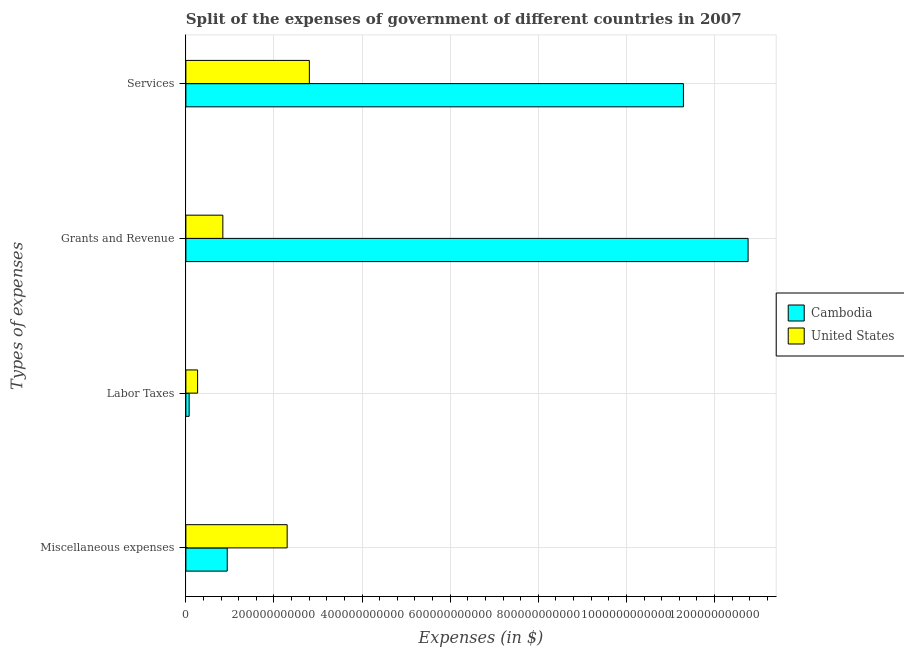How many different coloured bars are there?
Ensure brevity in your answer.  2. Are the number of bars per tick equal to the number of legend labels?
Your answer should be compact. Yes. How many bars are there on the 3rd tick from the top?
Keep it short and to the point. 2. How many bars are there on the 3rd tick from the bottom?
Offer a very short reply. 2. What is the label of the 3rd group of bars from the top?
Your answer should be very brief. Labor Taxes. What is the amount spent on services in Cambodia?
Offer a very short reply. 1.13e+12. Across all countries, what is the maximum amount spent on miscellaneous expenses?
Offer a very short reply. 2.30e+11. Across all countries, what is the minimum amount spent on grants and revenue?
Provide a short and direct response. 8.39e+1. In which country was the amount spent on miscellaneous expenses minimum?
Your answer should be compact. Cambodia. What is the total amount spent on labor taxes in the graph?
Offer a very short reply. 3.40e+1. What is the difference between the amount spent on services in United States and that in Cambodia?
Make the answer very short. -8.49e+11. What is the difference between the amount spent on miscellaneous expenses in Cambodia and the amount spent on services in United States?
Ensure brevity in your answer.  -1.86e+11. What is the average amount spent on services per country?
Provide a succinct answer. 7.05e+11. What is the difference between the amount spent on labor taxes and amount spent on grants and revenue in United States?
Provide a succinct answer. -5.73e+1. In how many countries, is the amount spent on grants and revenue greater than 1200000000000 $?
Your answer should be very brief. 1. What is the ratio of the amount spent on services in Cambodia to that in United States?
Provide a short and direct response. 4.03. Is the difference between the amount spent on miscellaneous expenses in Cambodia and United States greater than the difference between the amount spent on labor taxes in Cambodia and United States?
Offer a terse response. No. What is the difference between the highest and the second highest amount spent on miscellaneous expenses?
Your response must be concise. 1.36e+11. What is the difference between the highest and the lowest amount spent on grants and revenue?
Keep it short and to the point. 1.19e+12. In how many countries, is the amount spent on miscellaneous expenses greater than the average amount spent on miscellaneous expenses taken over all countries?
Keep it short and to the point. 1. Is the sum of the amount spent on grants and revenue in Cambodia and United States greater than the maximum amount spent on services across all countries?
Your response must be concise. Yes. What does the 2nd bar from the top in Services represents?
Ensure brevity in your answer.  Cambodia. What does the 1st bar from the bottom in Miscellaneous expenses represents?
Your answer should be very brief. Cambodia. How many bars are there?
Your answer should be very brief. 8. Are all the bars in the graph horizontal?
Give a very brief answer. Yes. What is the difference between two consecutive major ticks on the X-axis?
Make the answer very short. 2.00e+11. Does the graph contain any zero values?
Offer a terse response. No. Does the graph contain grids?
Offer a terse response. Yes. How many legend labels are there?
Provide a succinct answer. 2. How are the legend labels stacked?
Provide a short and direct response. Vertical. What is the title of the graph?
Provide a succinct answer. Split of the expenses of government of different countries in 2007. What is the label or title of the X-axis?
Offer a very short reply. Expenses (in $). What is the label or title of the Y-axis?
Ensure brevity in your answer.  Types of expenses. What is the Expenses (in $) of Cambodia in Miscellaneous expenses?
Your answer should be compact. 9.39e+1. What is the Expenses (in $) of United States in Miscellaneous expenses?
Make the answer very short. 2.30e+11. What is the Expenses (in $) in Cambodia in Labor Taxes?
Make the answer very short. 7.42e+09. What is the Expenses (in $) of United States in Labor Taxes?
Your answer should be compact. 2.66e+1. What is the Expenses (in $) of Cambodia in Grants and Revenue?
Ensure brevity in your answer.  1.28e+12. What is the Expenses (in $) of United States in Grants and Revenue?
Provide a short and direct response. 8.39e+1. What is the Expenses (in $) in Cambodia in Services?
Give a very brief answer. 1.13e+12. What is the Expenses (in $) in United States in Services?
Ensure brevity in your answer.  2.80e+11. Across all Types of expenses, what is the maximum Expenses (in $) in Cambodia?
Your answer should be compact. 1.28e+12. Across all Types of expenses, what is the maximum Expenses (in $) of United States?
Your answer should be very brief. 2.80e+11. Across all Types of expenses, what is the minimum Expenses (in $) in Cambodia?
Offer a very short reply. 7.42e+09. Across all Types of expenses, what is the minimum Expenses (in $) in United States?
Make the answer very short. 2.66e+1. What is the total Expenses (in $) of Cambodia in the graph?
Keep it short and to the point. 2.51e+12. What is the total Expenses (in $) in United States in the graph?
Make the answer very short. 6.21e+11. What is the difference between the Expenses (in $) of Cambodia in Miscellaneous expenses and that in Labor Taxes?
Provide a succinct answer. 8.64e+1. What is the difference between the Expenses (in $) of United States in Miscellaneous expenses and that in Labor Taxes?
Your answer should be very brief. 2.03e+11. What is the difference between the Expenses (in $) in Cambodia in Miscellaneous expenses and that in Grants and Revenue?
Make the answer very short. -1.18e+12. What is the difference between the Expenses (in $) of United States in Miscellaneous expenses and that in Grants and Revenue?
Make the answer very short. 1.46e+11. What is the difference between the Expenses (in $) in Cambodia in Miscellaneous expenses and that in Services?
Make the answer very short. -1.04e+12. What is the difference between the Expenses (in $) of United States in Miscellaneous expenses and that in Services?
Offer a very short reply. -5.04e+1. What is the difference between the Expenses (in $) in Cambodia in Labor Taxes and that in Grants and Revenue?
Provide a short and direct response. -1.27e+12. What is the difference between the Expenses (in $) in United States in Labor Taxes and that in Grants and Revenue?
Keep it short and to the point. -5.73e+1. What is the difference between the Expenses (in $) of Cambodia in Labor Taxes and that in Services?
Your response must be concise. -1.12e+12. What is the difference between the Expenses (in $) in United States in Labor Taxes and that in Services?
Give a very brief answer. -2.54e+11. What is the difference between the Expenses (in $) in Cambodia in Grants and Revenue and that in Services?
Offer a terse response. 1.47e+11. What is the difference between the Expenses (in $) in United States in Grants and Revenue and that in Services?
Offer a terse response. -1.96e+11. What is the difference between the Expenses (in $) of Cambodia in Miscellaneous expenses and the Expenses (in $) of United States in Labor Taxes?
Make the answer very short. 6.73e+1. What is the difference between the Expenses (in $) in Cambodia in Miscellaneous expenses and the Expenses (in $) in United States in Grants and Revenue?
Give a very brief answer. 9.97e+09. What is the difference between the Expenses (in $) of Cambodia in Miscellaneous expenses and the Expenses (in $) of United States in Services?
Your response must be concise. -1.86e+11. What is the difference between the Expenses (in $) of Cambodia in Labor Taxes and the Expenses (in $) of United States in Grants and Revenue?
Your response must be concise. -7.65e+1. What is the difference between the Expenses (in $) of Cambodia in Labor Taxes and the Expenses (in $) of United States in Services?
Keep it short and to the point. -2.73e+11. What is the difference between the Expenses (in $) of Cambodia in Grants and Revenue and the Expenses (in $) of United States in Services?
Provide a succinct answer. 9.96e+11. What is the average Expenses (in $) in Cambodia per Types of expenses?
Your answer should be very brief. 6.27e+11. What is the average Expenses (in $) in United States per Types of expenses?
Ensure brevity in your answer.  1.55e+11. What is the difference between the Expenses (in $) in Cambodia and Expenses (in $) in United States in Miscellaneous expenses?
Your answer should be compact. -1.36e+11. What is the difference between the Expenses (in $) in Cambodia and Expenses (in $) in United States in Labor Taxes?
Your answer should be very brief. -1.92e+1. What is the difference between the Expenses (in $) of Cambodia and Expenses (in $) of United States in Grants and Revenue?
Provide a short and direct response. 1.19e+12. What is the difference between the Expenses (in $) in Cambodia and Expenses (in $) in United States in Services?
Offer a very short reply. 8.49e+11. What is the ratio of the Expenses (in $) in Cambodia in Miscellaneous expenses to that in Labor Taxes?
Make the answer very short. 12.66. What is the ratio of the Expenses (in $) in United States in Miscellaneous expenses to that in Labor Taxes?
Provide a succinct answer. 8.64. What is the ratio of the Expenses (in $) of Cambodia in Miscellaneous expenses to that in Grants and Revenue?
Ensure brevity in your answer.  0.07. What is the ratio of the Expenses (in $) of United States in Miscellaneous expenses to that in Grants and Revenue?
Offer a terse response. 2.74. What is the ratio of the Expenses (in $) of Cambodia in Miscellaneous expenses to that in Services?
Offer a terse response. 0.08. What is the ratio of the Expenses (in $) in United States in Miscellaneous expenses to that in Services?
Keep it short and to the point. 0.82. What is the ratio of the Expenses (in $) of Cambodia in Labor Taxes to that in Grants and Revenue?
Give a very brief answer. 0.01. What is the ratio of the Expenses (in $) of United States in Labor Taxes to that in Grants and Revenue?
Ensure brevity in your answer.  0.32. What is the ratio of the Expenses (in $) in Cambodia in Labor Taxes to that in Services?
Offer a terse response. 0.01. What is the ratio of the Expenses (in $) in United States in Labor Taxes to that in Services?
Your answer should be very brief. 0.09. What is the ratio of the Expenses (in $) in Cambodia in Grants and Revenue to that in Services?
Your answer should be very brief. 1.13. What is the ratio of the Expenses (in $) of United States in Grants and Revenue to that in Services?
Provide a succinct answer. 0.3. What is the difference between the highest and the second highest Expenses (in $) of Cambodia?
Give a very brief answer. 1.47e+11. What is the difference between the highest and the second highest Expenses (in $) in United States?
Offer a very short reply. 5.04e+1. What is the difference between the highest and the lowest Expenses (in $) of Cambodia?
Your answer should be compact. 1.27e+12. What is the difference between the highest and the lowest Expenses (in $) in United States?
Your answer should be very brief. 2.54e+11. 